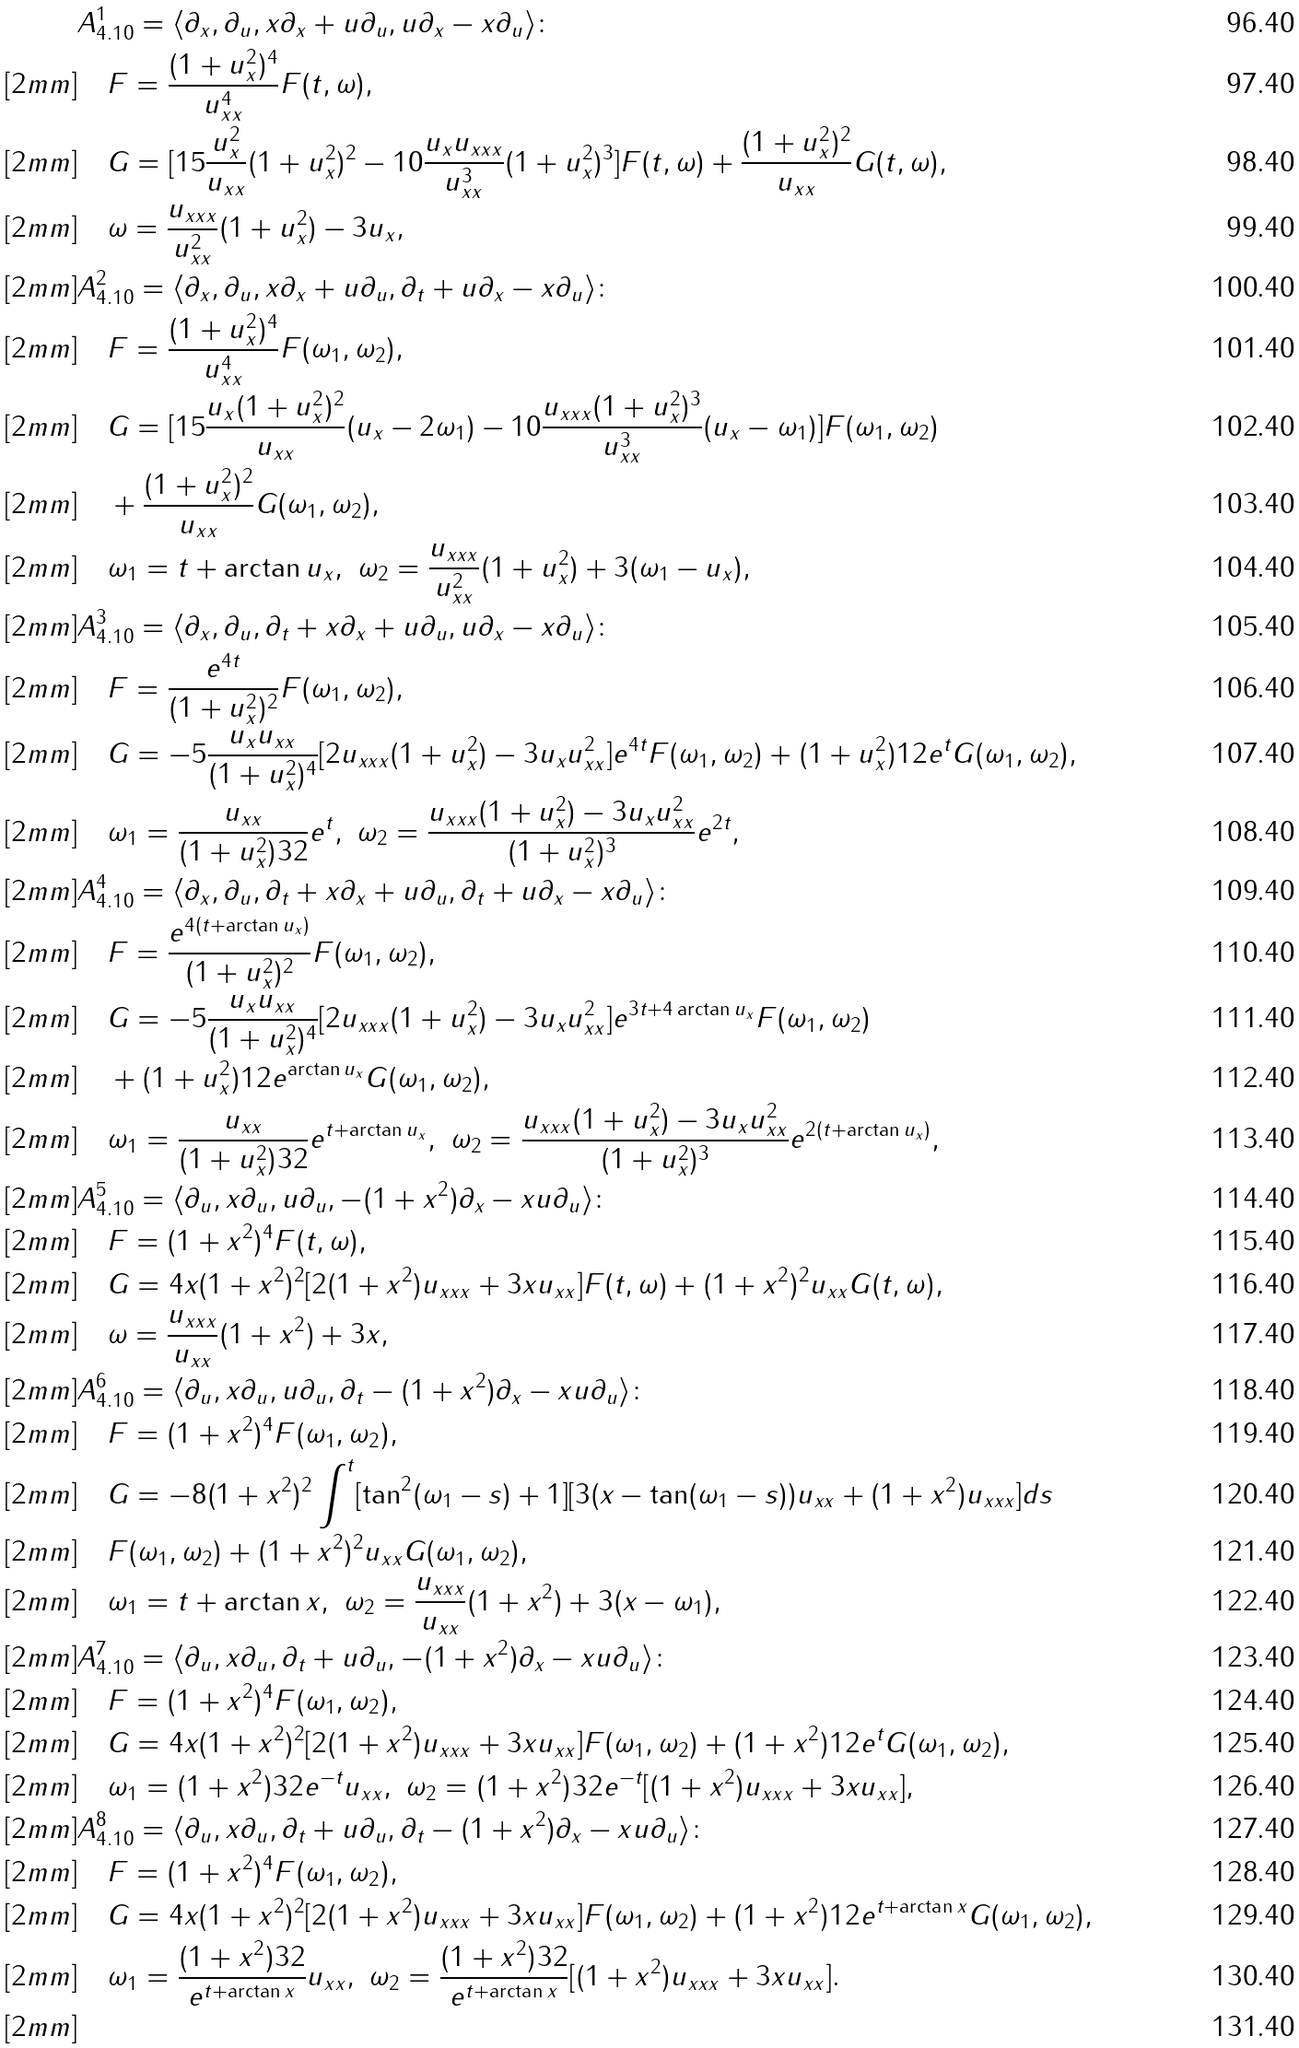Convert formula to latex. <formula><loc_0><loc_0><loc_500><loc_500>& A ^ { 1 } _ { 4 . 1 0 } = \langle \partial _ { x } , \partial _ { u } , x \partial _ { x } + u \partial _ { u } , u \partial _ { x } - x \partial _ { u } \rangle \colon \\ [ 2 m m ] & \quad F = \frac { ( 1 + u _ { x } ^ { 2 } ) ^ { 4 } } { u _ { x x } ^ { 4 } } F ( t , \omega ) , \\ [ 2 m m ] & \quad G = [ 1 5 \frac { u _ { x } ^ { 2 } } { u _ { x x } } ( 1 + u _ { x } ^ { 2 } ) ^ { 2 } - 1 0 \frac { u _ { x } u _ { x x x } } { u _ { x x } ^ { 3 } } ( 1 + u _ { x } ^ { 2 } ) ^ { 3 } ] F ( t , \omega ) + \frac { ( 1 + u _ { x } ^ { 2 } ) ^ { 2 } } { u _ { x x } } G ( t , \omega ) , \\ [ 2 m m ] & \quad \omega = \frac { u _ { x x x } } { u _ { x x } ^ { 2 } } ( 1 + u _ { x } ^ { 2 } ) - 3 u _ { x } , \\ [ 2 m m ] & A ^ { 2 } _ { 4 . 1 0 } = \langle \partial _ { x } , \partial _ { u } , x \partial _ { x } + u \partial _ { u } , \partial _ { t } + u \partial _ { x } - x \partial _ { u } \rangle \colon \\ [ 2 m m ] & \quad F = \frac { ( 1 + u _ { x } ^ { 2 } ) ^ { 4 } } { u _ { x x } ^ { 4 } } F ( \omega _ { 1 } , \omega _ { 2 } ) , \\ [ 2 m m ] & \quad G = [ 1 5 \frac { u _ { x } ( 1 + u _ { x } ^ { 2 } ) ^ { 2 } } { u _ { x x } } ( u _ { x } - 2 \omega _ { 1 } ) - 1 0 \frac { u _ { x x x } ( 1 + u _ { x } ^ { 2 } ) ^ { 3 } } { u _ { x x } ^ { 3 } } ( u _ { x } - \omega _ { 1 } ) ] F ( \omega _ { 1 } , \omega _ { 2 } ) \\ [ 2 m m ] & \quad + \frac { ( 1 + u _ { x } ^ { 2 } ) ^ { 2 } } { u _ { x x } } G ( \omega _ { 1 } , \omega _ { 2 } ) , \\ [ 2 m m ] & \quad \omega _ { 1 } = t + \arctan { u _ { x } } , \ \omega _ { 2 } = \frac { u _ { x x x } } { u _ { x x } ^ { 2 } } ( 1 + u _ { x } ^ { 2 } ) + 3 ( \omega _ { 1 } - u _ { x } ) , \\ [ 2 m m ] & A ^ { 3 } _ { 4 . 1 0 } = \langle \partial _ { x } , \partial _ { u } , \partial _ { t } + x \partial _ { x } + u \partial _ { u } , u \partial _ { x } - x \partial _ { u } \rangle \colon \\ [ 2 m m ] & \quad F = \frac { e ^ { 4 t } } { ( 1 + u _ { x } ^ { 2 } ) ^ { 2 } } F ( \omega _ { 1 } , \omega _ { 2 } ) , \\ [ 2 m m ] & \quad G = - 5 \frac { u _ { x } u _ { x x } } { ( 1 + u _ { x } ^ { 2 } ) ^ { 4 } } [ 2 u _ { x x x } ( 1 + u _ { x } ^ { 2 } ) - 3 u _ { x } u _ { x x } ^ { 2 } ] e ^ { 4 t } F ( \omega _ { 1 } , \omega _ { 2 } ) + ( 1 + u _ { x } ^ { 2 } ) ^ { } { 1 } 2 e ^ { t } G ( \omega _ { 1 } , \omega _ { 2 } ) , \\ [ 2 m m ] & \quad \omega _ { 1 } = \frac { u _ { x x } } { ( 1 + u _ { x } ^ { 2 } ) ^ { } { 3 } 2 } e ^ { t } , \ \omega _ { 2 } = \frac { u _ { x x x } ( 1 + u _ { x } ^ { 2 } ) - 3 u _ { x } u _ { x x } ^ { 2 } } { ( 1 + u _ { x } ^ { 2 } ) ^ { 3 } } e ^ { 2 t } , \\ [ 2 m m ] & A ^ { 4 } _ { 4 . 1 0 } = \langle \partial _ { x } , \partial _ { u } , \partial _ { t } + x \partial _ { x } + u \partial _ { u } , \partial _ { t } + u \partial _ { x } - x \partial _ { u } \rangle \colon \\ [ 2 m m ] & \quad F = \frac { e ^ { 4 ( t + \arctan { u _ { x } } ) } } { ( 1 + u _ { x } ^ { 2 } ) ^ { 2 } } F ( \omega _ { 1 } , \omega _ { 2 } ) , \\ [ 2 m m ] & \quad G = - 5 \frac { u _ { x } u _ { x x } } { ( 1 + u _ { x } ^ { 2 } ) ^ { 4 } } [ 2 u _ { x x x } ( 1 + u _ { x } ^ { 2 } ) - 3 u _ { x } u _ { x x } ^ { 2 } ] e ^ { 3 t + 4 \arctan { u _ { x } } } F ( \omega _ { 1 } , \omega _ { 2 } ) \\ [ 2 m m ] & \quad + ( 1 + u _ { x } ^ { 2 } ) ^ { } { 1 } 2 e ^ { \arctan { u _ { x } } } G ( \omega _ { 1 } , \omega _ { 2 } ) , \\ [ 2 m m ] & \quad \omega _ { 1 } = \frac { u _ { x x } } { ( 1 + u _ { x } ^ { 2 } ) ^ { } { 3 } 2 } e ^ { t + \arctan { u _ { x } } } , \ \omega _ { 2 } = \frac { u _ { x x x } ( 1 + u _ { x } ^ { 2 } ) - 3 u _ { x } u _ { x x } ^ { 2 } } { ( 1 + u _ { x } ^ { 2 } ) ^ { 3 } } e ^ { 2 ( t + \arctan { u _ { x } } ) } , \\ [ 2 m m ] & A ^ { 5 } _ { 4 . 1 0 } = \langle \partial _ { u } , x \partial _ { u } , u \partial _ { u } , - ( 1 + x ^ { 2 } ) \partial _ { x } - x u \partial _ { u } \rangle \colon \\ [ 2 m m ] & \quad F = ( 1 + x ^ { 2 } ) ^ { 4 } F ( t , \omega ) , \\ [ 2 m m ] & \quad G = 4 x ( 1 + x ^ { 2 } ) ^ { 2 } [ 2 ( 1 + x ^ { 2 } ) u _ { x x x } + 3 x u _ { x x } ] F ( t , \omega ) + ( 1 + x ^ { 2 } ) ^ { 2 } u _ { x x } G ( t , \omega ) , \\ [ 2 m m ] & \quad \omega = \frac { u _ { x x x } } { u _ { x x } } ( 1 + x ^ { 2 } ) + 3 x , \\ [ 2 m m ] & A ^ { 6 } _ { 4 . 1 0 } = \langle \partial _ { u } , x \partial _ { u } , u \partial _ { u } , \partial _ { t } - ( 1 + x ^ { 2 } ) \partial _ { x } - x u \partial _ { u } \rangle \colon \\ [ 2 m m ] & \quad F = ( 1 + x ^ { 2 } ) ^ { 4 } F ( \omega _ { 1 } , \omega _ { 2 } ) , \\ [ 2 m m ] & \quad G = - 8 ( 1 + x ^ { 2 } ) ^ { 2 } \int ^ { t } [ \tan ^ { 2 } ( \omega _ { 1 } - s ) + 1 ] [ 3 ( x - \tan ( \omega _ { 1 } - s ) ) u _ { x x } + ( 1 + x ^ { 2 } ) u _ { x x x } ] d s \\ [ 2 m m ] & \quad F ( \omega _ { 1 } , \omega _ { 2 } ) + ( 1 + x ^ { 2 } ) ^ { 2 } u _ { x x } G ( \omega _ { 1 } , \omega _ { 2 } ) , \\ [ 2 m m ] & \quad \omega _ { 1 } = t + \arctan { x } , \ \omega _ { 2 } = \frac { u _ { x x x } } { u _ { x x } } ( 1 + x ^ { 2 } ) + 3 ( x - \omega _ { 1 } ) , \\ [ 2 m m ] & A ^ { 7 } _ { 4 . 1 0 } = \langle \partial _ { u } , x \partial _ { u } , \partial _ { t } + u \partial _ { u } , - ( 1 + x ^ { 2 } ) \partial _ { x } - x u \partial _ { u } \rangle \colon \\ [ 2 m m ] & \quad F = ( 1 + x ^ { 2 } ) ^ { 4 } F ( \omega _ { 1 } , \omega _ { 2 } ) , \\ [ 2 m m ] & \quad G = 4 x ( 1 + x ^ { 2 } ) ^ { 2 } [ 2 ( 1 + x ^ { 2 } ) u _ { x x x } + 3 x u _ { x x } ] F ( \omega _ { 1 } , \omega _ { 2 } ) + ( 1 + x ^ { 2 } ) ^ { } { 1 } 2 e ^ { t } G ( \omega _ { 1 } , \omega _ { 2 } ) , \\ [ 2 m m ] & \quad \omega _ { 1 } = ( 1 + x ^ { 2 } ) ^ { } { 3 } 2 e ^ { - t } u _ { x x } , \ \omega _ { 2 } = ( 1 + x ^ { 2 } ) ^ { } { 3 } 2 e ^ { - t } [ ( 1 + x ^ { 2 } ) u _ { x x x } + 3 x u _ { x x } ] , \\ [ 2 m m ] & A ^ { 8 } _ { 4 . 1 0 } = \langle \partial _ { u } , x \partial _ { u } , \partial _ { t } + u \partial _ { u } , \partial _ { t } - ( 1 + x ^ { 2 } ) \partial _ { x } - x u \partial _ { u } \rangle \colon \\ [ 2 m m ] & \quad F = ( 1 + x ^ { 2 } ) ^ { 4 } F ( \omega _ { 1 } , \omega _ { 2 } ) , \\ [ 2 m m ] & \quad G = 4 x ( 1 + x ^ { 2 } ) ^ { 2 } [ 2 ( 1 + x ^ { 2 } ) u _ { x x x } + 3 x u _ { x x } ] F ( \omega _ { 1 } , \omega _ { 2 } ) + ( 1 + x ^ { 2 } ) ^ { } { 1 } 2 e ^ { t + \arctan x } G ( \omega _ { 1 } , \omega _ { 2 } ) , \\ [ 2 m m ] & \quad \omega _ { 1 } = \frac { ( 1 + x ^ { 2 } ) ^ { } { 3 } 2 } { e ^ { t + \arctan x } } u _ { x x } , \ \omega _ { 2 } = \frac { ( 1 + x ^ { 2 } ) ^ { } { 3 } 2 } { e ^ { t + \arctan x } } [ ( 1 + x ^ { 2 } ) u _ { x x x } + 3 x u _ { x x } ] . \\ [ 2 m m ]</formula> 